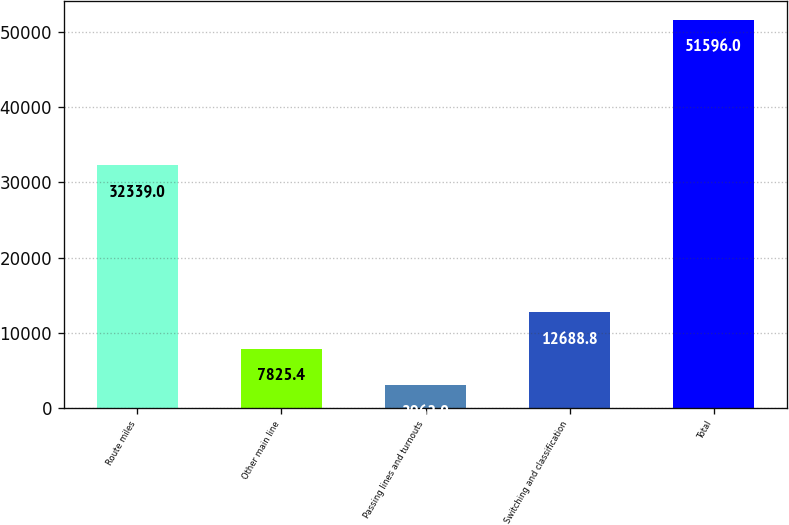<chart> <loc_0><loc_0><loc_500><loc_500><bar_chart><fcel>Route miles<fcel>Other main line<fcel>Passing lines and turnouts<fcel>Switching and classification<fcel>Total<nl><fcel>32339<fcel>7825.4<fcel>2962<fcel>12688.8<fcel>51596<nl></chart> 